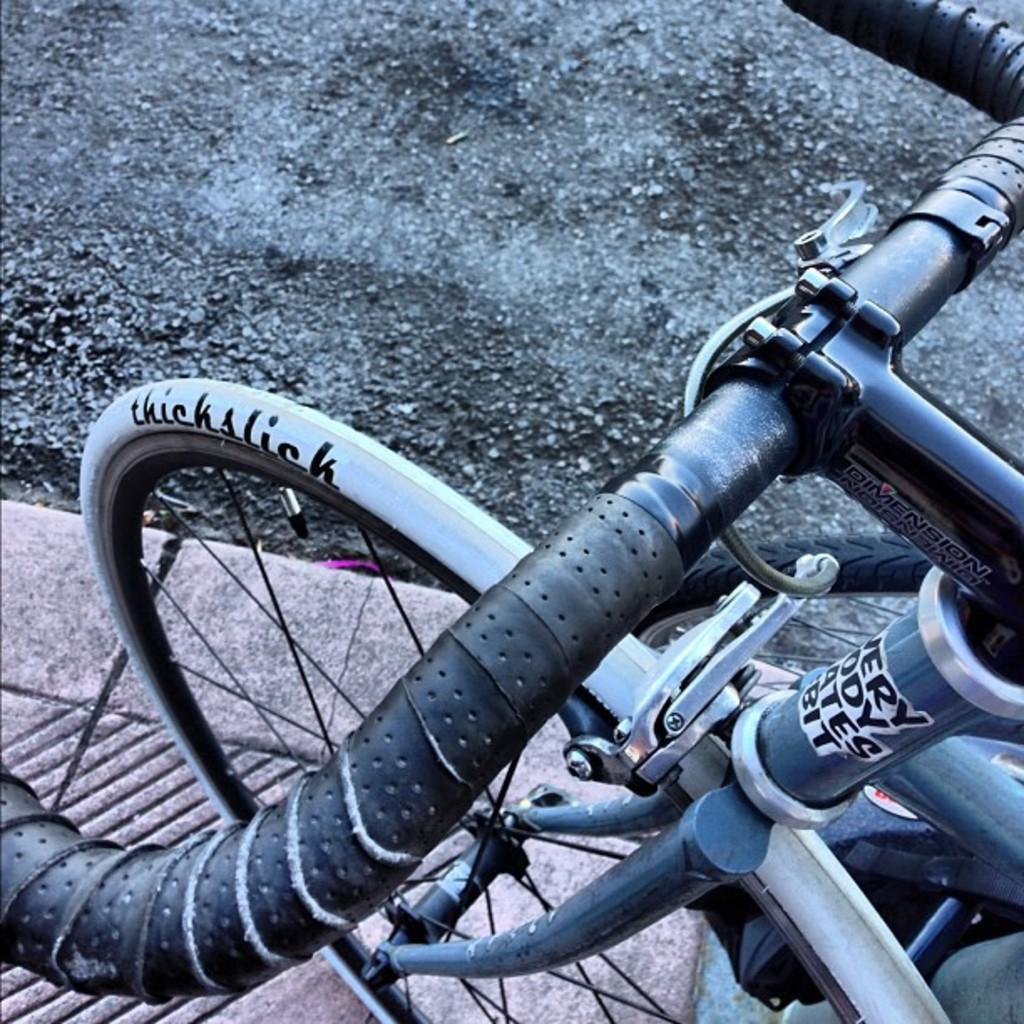What is the main subject in the foreground of the image? There is a bicycle in the foreground of the image. What type of path is visible at the bottom of the image? There is a footpath at the bottom of the image. What type of transportation route is visible at the top of the image? There is a road at the top of the image. Can you hear the bicycle crying in the image? There is no sound in the image, and bicycles do not have the ability to cry. 